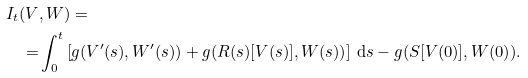<formula> <loc_0><loc_0><loc_500><loc_500>I _ { t } ( V & , W ) = \\ = & \int _ { 0 } ^ { t } \left [ g ( V ^ { \prime } ( s ) , W ^ { \prime } ( s ) ) + g ( R ( s ) [ V ( s ) ] , W ( s ) ) \right ] \, { \mathrm d } s - g ( S [ V ( 0 ) ] , W ( 0 ) ) .</formula> 